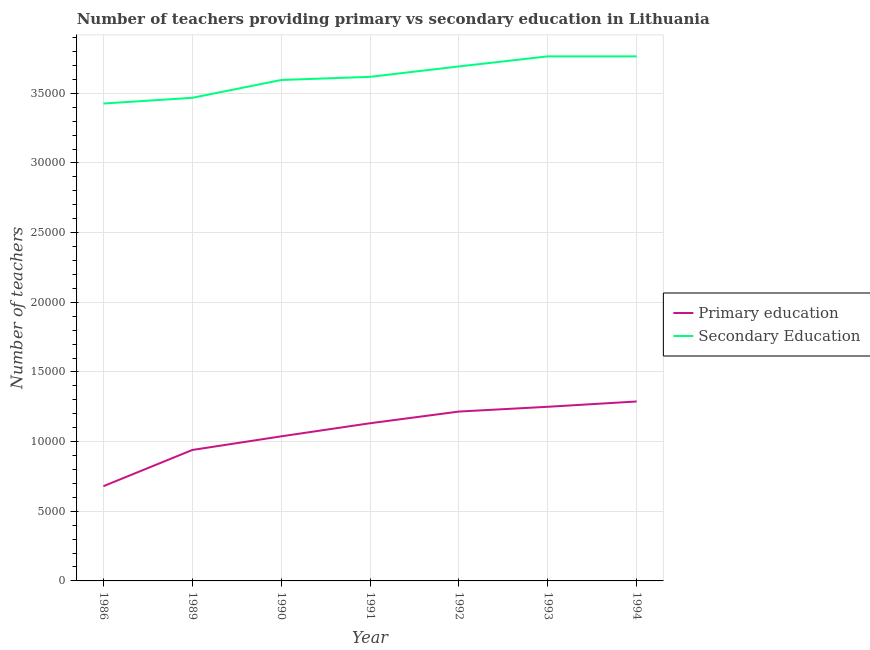Does the line corresponding to number of secondary teachers intersect with the line corresponding to number of primary teachers?
Keep it short and to the point. No. Is the number of lines equal to the number of legend labels?
Give a very brief answer. Yes. What is the number of primary teachers in 1992?
Your answer should be compact. 1.22e+04. Across all years, what is the maximum number of secondary teachers?
Offer a terse response. 3.77e+04. Across all years, what is the minimum number of primary teachers?
Your response must be concise. 6800. In which year was the number of secondary teachers minimum?
Your response must be concise. 1986. What is the total number of primary teachers in the graph?
Provide a short and direct response. 7.54e+04. What is the difference between the number of secondary teachers in 1990 and that in 1992?
Your answer should be very brief. -975. What is the difference between the number of primary teachers in 1989 and the number of secondary teachers in 1990?
Provide a succinct answer. -2.66e+04. What is the average number of primary teachers per year?
Offer a very short reply. 1.08e+04. In the year 1992, what is the difference between the number of secondary teachers and number of primary teachers?
Offer a very short reply. 2.48e+04. What is the ratio of the number of secondary teachers in 1986 to that in 1992?
Ensure brevity in your answer.  0.93. Is the difference between the number of primary teachers in 1990 and 1993 greater than the difference between the number of secondary teachers in 1990 and 1993?
Offer a very short reply. No. What is the difference between the highest and the second highest number of primary teachers?
Offer a terse response. 381. What is the difference between the highest and the lowest number of secondary teachers?
Provide a short and direct response. 3385. Is the sum of the number of secondary teachers in 1990 and 1991 greater than the maximum number of primary teachers across all years?
Your answer should be very brief. Yes. Does the number of secondary teachers monotonically increase over the years?
Your response must be concise. No. Is the number of secondary teachers strictly greater than the number of primary teachers over the years?
Provide a succinct answer. Yes. Is the number of secondary teachers strictly less than the number of primary teachers over the years?
Make the answer very short. No. What is the difference between two consecutive major ticks on the Y-axis?
Give a very brief answer. 5000. Does the graph contain grids?
Offer a terse response. Yes. How many legend labels are there?
Give a very brief answer. 2. How are the legend labels stacked?
Your response must be concise. Vertical. What is the title of the graph?
Provide a succinct answer. Number of teachers providing primary vs secondary education in Lithuania. Does "Arms exports" appear as one of the legend labels in the graph?
Offer a very short reply. No. What is the label or title of the X-axis?
Offer a very short reply. Year. What is the label or title of the Y-axis?
Provide a short and direct response. Number of teachers. What is the Number of teachers in Primary education in 1986?
Make the answer very short. 6800. What is the Number of teachers of Secondary Education in 1986?
Give a very brief answer. 3.43e+04. What is the Number of teachers of Primary education in 1989?
Give a very brief answer. 9400. What is the Number of teachers of Secondary Education in 1989?
Keep it short and to the point. 3.47e+04. What is the Number of teachers in Primary education in 1990?
Make the answer very short. 1.04e+04. What is the Number of teachers of Secondary Education in 1990?
Provide a succinct answer. 3.60e+04. What is the Number of teachers of Primary education in 1991?
Provide a succinct answer. 1.13e+04. What is the Number of teachers in Secondary Education in 1991?
Provide a short and direct response. 3.62e+04. What is the Number of teachers of Primary education in 1992?
Give a very brief answer. 1.22e+04. What is the Number of teachers of Secondary Education in 1992?
Ensure brevity in your answer.  3.69e+04. What is the Number of teachers in Primary education in 1993?
Give a very brief answer. 1.25e+04. What is the Number of teachers of Secondary Education in 1993?
Offer a very short reply. 3.77e+04. What is the Number of teachers of Primary education in 1994?
Provide a short and direct response. 1.29e+04. What is the Number of teachers in Secondary Education in 1994?
Ensure brevity in your answer.  3.77e+04. Across all years, what is the maximum Number of teachers of Primary education?
Provide a short and direct response. 1.29e+04. Across all years, what is the maximum Number of teachers in Secondary Education?
Provide a short and direct response. 3.77e+04. Across all years, what is the minimum Number of teachers in Primary education?
Your answer should be very brief. 6800. Across all years, what is the minimum Number of teachers in Secondary Education?
Give a very brief answer. 3.43e+04. What is the total Number of teachers of Primary education in the graph?
Provide a succinct answer. 7.54e+04. What is the total Number of teachers in Secondary Education in the graph?
Make the answer very short. 2.53e+05. What is the difference between the Number of teachers in Primary education in 1986 and that in 1989?
Give a very brief answer. -2600. What is the difference between the Number of teachers of Secondary Education in 1986 and that in 1989?
Provide a short and direct response. -410. What is the difference between the Number of teachers of Primary education in 1986 and that in 1990?
Offer a terse response. -3578. What is the difference between the Number of teachers of Secondary Education in 1986 and that in 1990?
Provide a short and direct response. -1688. What is the difference between the Number of teachers in Primary education in 1986 and that in 1991?
Keep it short and to the point. -4519. What is the difference between the Number of teachers of Secondary Education in 1986 and that in 1991?
Offer a terse response. -1916. What is the difference between the Number of teachers in Primary education in 1986 and that in 1992?
Your response must be concise. -5358. What is the difference between the Number of teachers of Secondary Education in 1986 and that in 1992?
Keep it short and to the point. -2663. What is the difference between the Number of teachers in Primary education in 1986 and that in 1993?
Provide a short and direct response. -5700. What is the difference between the Number of teachers in Secondary Education in 1986 and that in 1993?
Provide a short and direct response. -3385. What is the difference between the Number of teachers of Primary education in 1986 and that in 1994?
Offer a terse response. -6081. What is the difference between the Number of teachers of Secondary Education in 1986 and that in 1994?
Give a very brief answer. -3385. What is the difference between the Number of teachers in Primary education in 1989 and that in 1990?
Offer a terse response. -978. What is the difference between the Number of teachers of Secondary Education in 1989 and that in 1990?
Offer a very short reply. -1278. What is the difference between the Number of teachers of Primary education in 1989 and that in 1991?
Offer a terse response. -1919. What is the difference between the Number of teachers of Secondary Education in 1989 and that in 1991?
Provide a succinct answer. -1506. What is the difference between the Number of teachers of Primary education in 1989 and that in 1992?
Give a very brief answer. -2758. What is the difference between the Number of teachers of Secondary Education in 1989 and that in 1992?
Ensure brevity in your answer.  -2253. What is the difference between the Number of teachers of Primary education in 1989 and that in 1993?
Keep it short and to the point. -3100. What is the difference between the Number of teachers in Secondary Education in 1989 and that in 1993?
Your response must be concise. -2975. What is the difference between the Number of teachers in Primary education in 1989 and that in 1994?
Provide a short and direct response. -3481. What is the difference between the Number of teachers of Secondary Education in 1989 and that in 1994?
Offer a very short reply. -2975. What is the difference between the Number of teachers in Primary education in 1990 and that in 1991?
Make the answer very short. -941. What is the difference between the Number of teachers of Secondary Education in 1990 and that in 1991?
Offer a very short reply. -228. What is the difference between the Number of teachers in Primary education in 1990 and that in 1992?
Make the answer very short. -1780. What is the difference between the Number of teachers of Secondary Education in 1990 and that in 1992?
Keep it short and to the point. -975. What is the difference between the Number of teachers of Primary education in 1990 and that in 1993?
Your answer should be very brief. -2122. What is the difference between the Number of teachers of Secondary Education in 1990 and that in 1993?
Ensure brevity in your answer.  -1697. What is the difference between the Number of teachers of Primary education in 1990 and that in 1994?
Provide a succinct answer. -2503. What is the difference between the Number of teachers of Secondary Education in 1990 and that in 1994?
Provide a short and direct response. -1697. What is the difference between the Number of teachers of Primary education in 1991 and that in 1992?
Give a very brief answer. -839. What is the difference between the Number of teachers of Secondary Education in 1991 and that in 1992?
Ensure brevity in your answer.  -747. What is the difference between the Number of teachers of Primary education in 1991 and that in 1993?
Your response must be concise. -1181. What is the difference between the Number of teachers of Secondary Education in 1991 and that in 1993?
Give a very brief answer. -1469. What is the difference between the Number of teachers in Primary education in 1991 and that in 1994?
Your response must be concise. -1562. What is the difference between the Number of teachers of Secondary Education in 1991 and that in 1994?
Your answer should be very brief. -1469. What is the difference between the Number of teachers in Primary education in 1992 and that in 1993?
Your answer should be very brief. -342. What is the difference between the Number of teachers in Secondary Education in 1992 and that in 1993?
Offer a terse response. -722. What is the difference between the Number of teachers in Primary education in 1992 and that in 1994?
Your response must be concise. -723. What is the difference between the Number of teachers of Secondary Education in 1992 and that in 1994?
Provide a short and direct response. -722. What is the difference between the Number of teachers in Primary education in 1993 and that in 1994?
Ensure brevity in your answer.  -381. What is the difference between the Number of teachers in Secondary Education in 1993 and that in 1994?
Your answer should be very brief. 0. What is the difference between the Number of teachers in Primary education in 1986 and the Number of teachers in Secondary Education in 1989?
Provide a succinct answer. -2.79e+04. What is the difference between the Number of teachers in Primary education in 1986 and the Number of teachers in Secondary Education in 1990?
Provide a short and direct response. -2.92e+04. What is the difference between the Number of teachers in Primary education in 1986 and the Number of teachers in Secondary Education in 1991?
Ensure brevity in your answer.  -2.94e+04. What is the difference between the Number of teachers in Primary education in 1986 and the Number of teachers in Secondary Education in 1992?
Keep it short and to the point. -3.01e+04. What is the difference between the Number of teachers in Primary education in 1986 and the Number of teachers in Secondary Education in 1993?
Offer a terse response. -3.09e+04. What is the difference between the Number of teachers of Primary education in 1986 and the Number of teachers of Secondary Education in 1994?
Offer a terse response. -3.09e+04. What is the difference between the Number of teachers of Primary education in 1989 and the Number of teachers of Secondary Education in 1990?
Offer a terse response. -2.66e+04. What is the difference between the Number of teachers of Primary education in 1989 and the Number of teachers of Secondary Education in 1991?
Your response must be concise. -2.68e+04. What is the difference between the Number of teachers in Primary education in 1989 and the Number of teachers in Secondary Education in 1992?
Ensure brevity in your answer.  -2.75e+04. What is the difference between the Number of teachers in Primary education in 1989 and the Number of teachers in Secondary Education in 1993?
Offer a terse response. -2.83e+04. What is the difference between the Number of teachers of Primary education in 1989 and the Number of teachers of Secondary Education in 1994?
Ensure brevity in your answer.  -2.83e+04. What is the difference between the Number of teachers of Primary education in 1990 and the Number of teachers of Secondary Education in 1991?
Provide a short and direct response. -2.58e+04. What is the difference between the Number of teachers in Primary education in 1990 and the Number of teachers in Secondary Education in 1992?
Keep it short and to the point. -2.66e+04. What is the difference between the Number of teachers in Primary education in 1990 and the Number of teachers in Secondary Education in 1993?
Keep it short and to the point. -2.73e+04. What is the difference between the Number of teachers in Primary education in 1990 and the Number of teachers in Secondary Education in 1994?
Your answer should be very brief. -2.73e+04. What is the difference between the Number of teachers in Primary education in 1991 and the Number of teachers in Secondary Education in 1992?
Offer a very short reply. -2.56e+04. What is the difference between the Number of teachers in Primary education in 1991 and the Number of teachers in Secondary Education in 1993?
Give a very brief answer. -2.63e+04. What is the difference between the Number of teachers of Primary education in 1991 and the Number of teachers of Secondary Education in 1994?
Your answer should be compact. -2.63e+04. What is the difference between the Number of teachers in Primary education in 1992 and the Number of teachers in Secondary Education in 1993?
Offer a very short reply. -2.55e+04. What is the difference between the Number of teachers in Primary education in 1992 and the Number of teachers in Secondary Education in 1994?
Your answer should be compact. -2.55e+04. What is the difference between the Number of teachers of Primary education in 1993 and the Number of teachers of Secondary Education in 1994?
Make the answer very short. -2.52e+04. What is the average Number of teachers of Primary education per year?
Provide a succinct answer. 1.08e+04. What is the average Number of teachers of Secondary Education per year?
Offer a terse response. 3.62e+04. In the year 1986, what is the difference between the Number of teachers in Primary education and Number of teachers in Secondary Education?
Make the answer very short. -2.75e+04. In the year 1989, what is the difference between the Number of teachers in Primary education and Number of teachers in Secondary Education?
Your answer should be compact. -2.53e+04. In the year 1990, what is the difference between the Number of teachers in Primary education and Number of teachers in Secondary Education?
Offer a terse response. -2.56e+04. In the year 1991, what is the difference between the Number of teachers of Primary education and Number of teachers of Secondary Education?
Your response must be concise. -2.49e+04. In the year 1992, what is the difference between the Number of teachers of Primary education and Number of teachers of Secondary Education?
Make the answer very short. -2.48e+04. In the year 1993, what is the difference between the Number of teachers of Primary education and Number of teachers of Secondary Education?
Keep it short and to the point. -2.52e+04. In the year 1994, what is the difference between the Number of teachers in Primary education and Number of teachers in Secondary Education?
Your response must be concise. -2.48e+04. What is the ratio of the Number of teachers of Primary education in 1986 to that in 1989?
Ensure brevity in your answer.  0.72. What is the ratio of the Number of teachers in Primary education in 1986 to that in 1990?
Provide a short and direct response. 0.66. What is the ratio of the Number of teachers of Secondary Education in 1986 to that in 1990?
Offer a very short reply. 0.95. What is the ratio of the Number of teachers in Primary education in 1986 to that in 1991?
Give a very brief answer. 0.6. What is the ratio of the Number of teachers in Secondary Education in 1986 to that in 1991?
Keep it short and to the point. 0.95. What is the ratio of the Number of teachers in Primary education in 1986 to that in 1992?
Your answer should be very brief. 0.56. What is the ratio of the Number of teachers in Secondary Education in 1986 to that in 1992?
Your answer should be very brief. 0.93. What is the ratio of the Number of teachers of Primary education in 1986 to that in 1993?
Offer a terse response. 0.54. What is the ratio of the Number of teachers of Secondary Education in 1986 to that in 1993?
Your response must be concise. 0.91. What is the ratio of the Number of teachers in Primary education in 1986 to that in 1994?
Ensure brevity in your answer.  0.53. What is the ratio of the Number of teachers in Secondary Education in 1986 to that in 1994?
Provide a short and direct response. 0.91. What is the ratio of the Number of teachers in Primary education in 1989 to that in 1990?
Offer a very short reply. 0.91. What is the ratio of the Number of teachers in Secondary Education in 1989 to that in 1990?
Offer a terse response. 0.96. What is the ratio of the Number of teachers of Primary education in 1989 to that in 1991?
Your answer should be very brief. 0.83. What is the ratio of the Number of teachers in Secondary Education in 1989 to that in 1991?
Provide a succinct answer. 0.96. What is the ratio of the Number of teachers in Primary education in 1989 to that in 1992?
Provide a short and direct response. 0.77. What is the ratio of the Number of teachers of Secondary Education in 1989 to that in 1992?
Your response must be concise. 0.94. What is the ratio of the Number of teachers of Primary education in 1989 to that in 1993?
Provide a succinct answer. 0.75. What is the ratio of the Number of teachers of Secondary Education in 1989 to that in 1993?
Your response must be concise. 0.92. What is the ratio of the Number of teachers of Primary education in 1989 to that in 1994?
Give a very brief answer. 0.73. What is the ratio of the Number of teachers in Secondary Education in 1989 to that in 1994?
Keep it short and to the point. 0.92. What is the ratio of the Number of teachers of Primary education in 1990 to that in 1991?
Ensure brevity in your answer.  0.92. What is the ratio of the Number of teachers of Secondary Education in 1990 to that in 1991?
Ensure brevity in your answer.  0.99. What is the ratio of the Number of teachers in Primary education in 1990 to that in 1992?
Your response must be concise. 0.85. What is the ratio of the Number of teachers in Secondary Education in 1990 to that in 1992?
Give a very brief answer. 0.97. What is the ratio of the Number of teachers in Primary education in 1990 to that in 1993?
Your response must be concise. 0.83. What is the ratio of the Number of teachers in Secondary Education in 1990 to that in 1993?
Offer a very short reply. 0.95. What is the ratio of the Number of teachers of Primary education in 1990 to that in 1994?
Provide a succinct answer. 0.81. What is the ratio of the Number of teachers of Secondary Education in 1990 to that in 1994?
Make the answer very short. 0.95. What is the ratio of the Number of teachers of Secondary Education in 1991 to that in 1992?
Offer a very short reply. 0.98. What is the ratio of the Number of teachers of Primary education in 1991 to that in 1993?
Make the answer very short. 0.91. What is the ratio of the Number of teachers in Primary education in 1991 to that in 1994?
Your answer should be compact. 0.88. What is the ratio of the Number of teachers of Secondary Education in 1991 to that in 1994?
Ensure brevity in your answer.  0.96. What is the ratio of the Number of teachers in Primary education in 1992 to that in 1993?
Provide a succinct answer. 0.97. What is the ratio of the Number of teachers in Secondary Education in 1992 to that in 1993?
Your answer should be very brief. 0.98. What is the ratio of the Number of teachers of Primary education in 1992 to that in 1994?
Your answer should be compact. 0.94. What is the ratio of the Number of teachers in Secondary Education in 1992 to that in 1994?
Provide a short and direct response. 0.98. What is the ratio of the Number of teachers of Primary education in 1993 to that in 1994?
Offer a very short reply. 0.97. What is the ratio of the Number of teachers of Secondary Education in 1993 to that in 1994?
Offer a terse response. 1. What is the difference between the highest and the second highest Number of teachers in Primary education?
Give a very brief answer. 381. What is the difference between the highest and the lowest Number of teachers in Primary education?
Keep it short and to the point. 6081. What is the difference between the highest and the lowest Number of teachers of Secondary Education?
Your answer should be compact. 3385. 